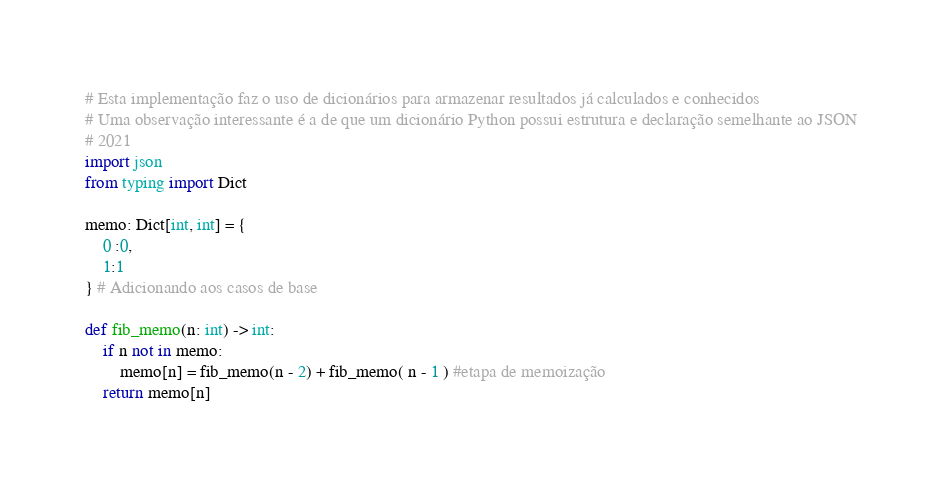Convert code to text. <code><loc_0><loc_0><loc_500><loc_500><_Python_># Esta implementação faz o uso de dicionários para armazenar resultados já calculados e conhecidos
# Uma observação interessante é a de que um dicionário Python possui estrutura e declaração semelhante ao JSON 
# 2021
import json
from typing import Dict 

memo: Dict[int, int] = {
    0 :0, 
    1:1
} # Adicionando aos casos de base 

def fib_memo(n: int) -> int:
    if n not in memo:
        memo[n] = fib_memo(n - 2) + fib_memo( n - 1 ) #etapa de memoização 
    return memo[n]

</code> 